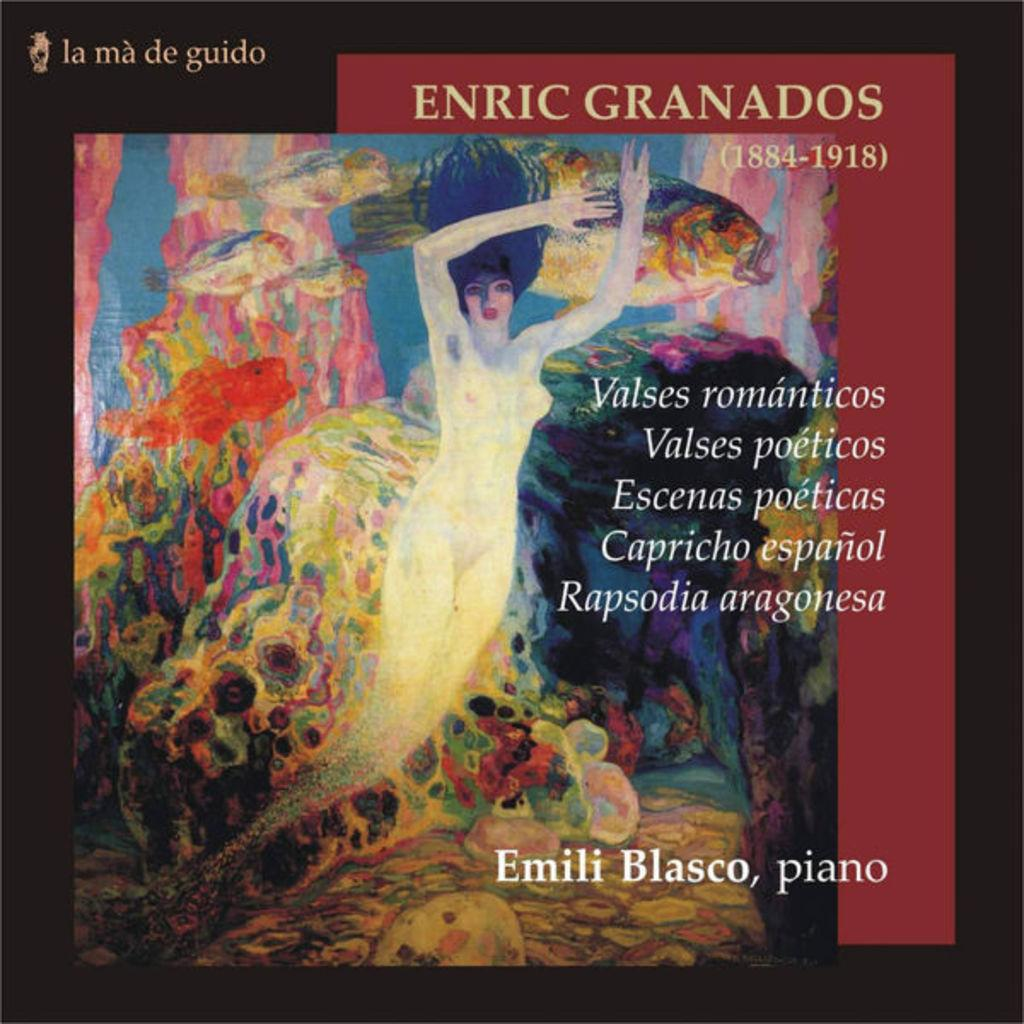<image>
Present a compact description of the photo's key features. some kind of art piece that says Enric Granados at the top 